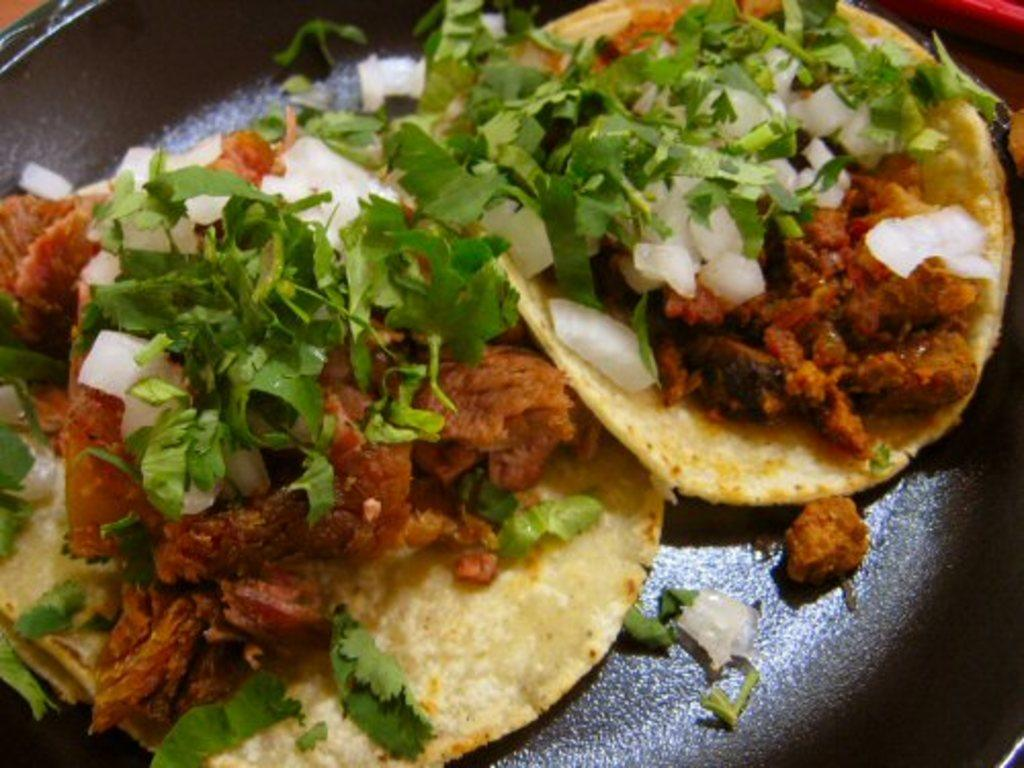What can be seen in the image related to food? There are two food items in the image. Are the food items different or the same? The food items are the same. Where are the food items located in the image? The food items are on a platform. What is the daughter of the carpenter doing with the jellyfish in the image? There is no daughter, carpenter, or jellyfish present in the image. 